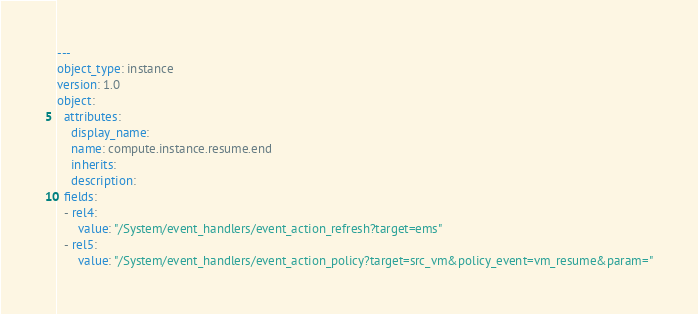<code> <loc_0><loc_0><loc_500><loc_500><_YAML_>---
object_type: instance
version: 1.0
object:
  attributes:
    display_name: 
    name: compute.instance.resume.end
    inherits: 
    description: 
  fields:
  - rel4:
      value: "/System/event_handlers/event_action_refresh?target=ems"
  - rel5:
      value: "/System/event_handlers/event_action_policy?target=src_vm&policy_event=vm_resume&param="
</code> 